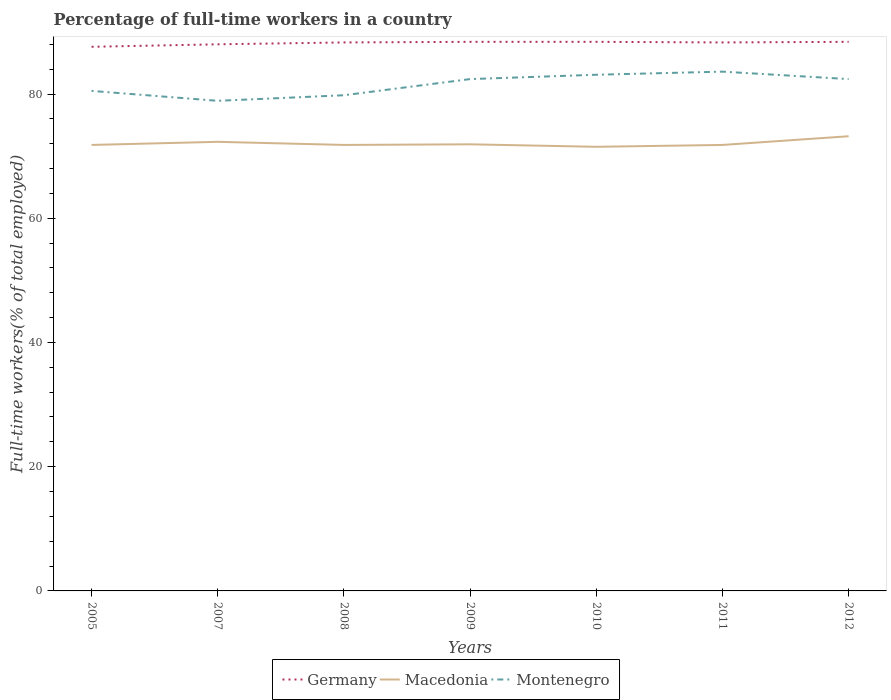Across all years, what is the maximum percentage of full-time workers in Montenegro?
Your answer should be very brief. 78.9. In which year was the percentage of full-time workers in Macedonia maximum?
Ensure brevity in your answer.  2010. What is the total percentage of full-time workers in Montenegro in the graph?
Your answer should be compact. -1.9. What is the difference between the highest and the second highest percentage of full-time workers in Montenegro?
Provide a short and direct response. 4.7. What is the difference between the highest and the lowest percentage of full-time workers in Montenegro?
Your answer should be very brief. 4. Are the values on the major ticks of Y-axis written in scientific E-notation?
Offer a very short reply. No. Does the graph contain grids?
Keep it short and to the point. No. What is the title of the graph?
Give a very brief answer. Percentage of full-time workers in a country. Does "St. Kitts and Nevis" appear as one of the legend labels in the graph?
Provide a short and direct response. No. What is the label or title of the Y-axis?
Keep it short and to the point. Full-time workers(% of total employed). What is the Full-time workers(% of total employed) of Germany in 2005?
Your answer should be very brief. 87.6. What is the Full-time workers(% of total employed) in Macedonia in 2005?
Ensure brevity in your answer.  71.8. What is the Full-time workers(% of total employed) of Montenegro in 2005?
Your answer should be compact. 80.5. What is the Full-time workers(% of total employed) in Germany in 2007?
Your answer should be very brief. 88. What is the Full-time workers(% of total employed) of Macedonia in 2007?
Provide a short and direct response. 72.3. What is the Full-time workers(% of total employed) of Montenegro in 2007?
Ensure brevity in your answer.  78.9. What is the Full-time workers(% of total employed) in Germany in 2008?
Ensure brevity in your answer.  88.3. What is the Full-time workers(% of total employed) of Macedonia in 2008?
Provide a short and direct response. 71.8. What is the Full-time workers(% of total employed) in Montenegro in 2008?
Provide a succinct answer. 79.8. What is the Full-time workers(% of total employed) in Germany in 2009?
Provide a succinct answer. 88.4. What is the Full-time workers(% of total employed) of Macedonia in 2009?
Ensure brevity in your answer.  71.9. What is the Full-time workers(% of total employed) of Montenegro in 2009?
Provide a short and direct response. 82.4. What is the Full-time workers(% of total employed) in Germany in 2010?
Ensure brevity in your answer.  88.4. What is the Full-time workers(% of total employed) in Macedonia in 2010?
Your answer should be compact. 71.5. What is the Full-time workers(% of total employed) of Montenegro in 2010?
Your answer should be very brief. 83.1. What is the Full-time workers(% of total employed) in Germany in 2011?
Your response must be concise. 88.3. What is the Full-time workers(% of total employed) in Macedonia in 2011?
Your response must be concise. 71.8. What is the Full-time workers(% of total employed) of Montenegro in 2011?
Ensure brevity in your answer.  83.6. What is the Full-time workers(% of total employed) in Germany in 2012?
Make the answer very short. 88.4. What is the Full-time workers(% of total employed) of Macedonia in 2012?
Offer a very short reply. 73.2. What is the Full-time workers(% of total employed) of Montenegro in 2012?
Make the answer very short. 82.4. Across all years, what is the maximum Full-time workers(% of total employed) in Germany?
Provide a short and direct response. 88.4. Across all years, what is the maximum Full-time workers(% of total employed) in Macedonia?
Make the answer very short. 73.2. Across all years, what is the maximum Full-time workers(% of total employed) of Montenegro?
Your response must be concise. 83.6. Across all years, what is the minimum Full-time workers(% of total employed) of Germany?
Ensure brevity in your answer.  87.6. Across all years, what is the minimum Full-time workers(% of total employed) in Macedonia?
Your response must be concise. 71.5. Across all years, what is the minimum Full-time workers(% of total employed) of Montenegro?
Your response must be concise. 78.9. What is the total Full-time workers(% of total employed) of Germany in the graph?
Provide a short and direct response. 617.4. What is the total Full-time workers(% of total employed) of Macedonia in the graph?
Your response must be concise. 504.3. What is the total Full-time workers(% of total employed) in Montenegro in the graph?
Ensure brevity in your answer.  570.7. What is the difference between the Full-time workers(% of total employed) in Montenegro in 2005 and that in 2007?
Provide a short and direct response. 1.6. What is the difference between the Full-time workers(% of total employed) of Macedonia in 2005 and that in 2008?
Offer a terse response. 0. What is the difference between the Full-time workers(% of total employed) in Montenegro in 2005 and that in 2008?
Offer a very short reply. 0.7. What is the difference between the Full-time workers(% of total employed) in Germany in 2005 and that in 2009?
Offer a terse response. -0.8. What is the difference between the Full-time workers(% of total employed) in Montenegro in 2005 and that in 2009?
Offer a very short reply. -1.9. What is the difference between the Full-time workers(% of total employed) in Germany in 2005 and that in 2011?
Provide a succinct answer. -0.7. What is the difference between the Full-time workers(% of total employed) of Macedonia in 2005 and that in 2011?
Provide a succinct answer. 0. What is the difference between the Full-time workers(% of total employed) of Macedonia in 2005 and that in 2012?
Offer a very short reply. -1.4. What is the difference between the Full-time workers(% of total employed) in Montenegro in 2005 and that in 2012?
Your response must be concise. -1.9. What is the difference between the Full-time workers(% of total employed) in Germany in 2007 and that in 2008?
Offer a very short reply. -0.3. What is the difference between the Full-time workers(% of total employed) of Germany in 2007 and that in 2009?
Keep it short and to the point. -0.4. What is the difference between the Full-time workers(% of total employed) in Macedonia in 2007 and that in 2009?
Provide a short and direct response. 0.4. What is the difference between the Full-time workers(% of total employed) in Montenegro in 2007 and that in 2009?
Your response must be concise. -3.5. What is the difference between the Full-time workers(% of total employed) of Montenegro in 2007 and that in 2010?
Make the answer very short. -4.2. What is the difference between the Full-time workers(% of total employed) in Germany in 2007 and that in 2011?
Offer a very short reply. -0.3. What is the difference between the Full-time workers(% of total employed) of Germany in 2007 and that in 2012?
Your response must be concise. -0.4. What is the difference between the Full-time workers(% of total employed) of Montenegro in 2007 and that in 2012?
Provide a succinct answer. -3.5. What is the difference between the Full-time workers(% of total employed) of Germany in 2008 and that in 2009?
Ensure brevity in your answer.  -0.1. What is the difference between the Full-time workers(% of total employed) in Montenegro in 2008 and that in 2009?
Your answer should be compact. -2.6. What is the difference between the Full-time workers(% of total employed) of Germany in 2008 and that in 2010?
Ensure brevity in your answer.  -0.1. What is the difference between the Full-time workers(% of total employed) in Macedonia in 2008 and that in 2010?
Offer a very short reply. 0.3. What is the difference between the Full-time workers(% of total employed) in Montenegro in 2008 and that in 2010?
Give a very brief answer. -3.3. What is the difference between the Full-time workers(% of total employed) of Germany in 2008 and that in 2011?
Keep it short and to the point. 0. What is the difference between the Full-time workers(% of total employed) in Montenegro in 2008 and that in 2011?
Keep it short and to the point. -3.8. What is the difference between the Full-time workers(% of total employed) in Macedonia in 2008 and that in 2012?
Ensure brevity in your answer.  -1.4. What is the difference between the Full-time workers(% of total employed) of Montenegro in 2009 and that in 2010?
Provide a succinct answer. -0.7. What is the difference between the Full-time workers(% of total employed) of Germany in 2009 and that in 2011?
Ensure brevity in your answer.  0.1. What is the difference between the Full-time workers(% of total employed) in Macedonia in 2009 and that in 2011?
Provide a succinct answer. 0.1. What is the difference between the Full-time workers(% of total employed) in Montenegro in 2009 and that in 2011?
Make the answer very short. -1.2. What is the difference between the Full-time workers(% of total employed) in Germany in 2009 and that in 2012?
Your response must be concise. 0. What is the difference between the Full-time workers(% of total employed) of Macedonia in 2010 and that in 2011?
Provide a succinct answer. -0.3. What is the difference between the Full-time workers(% of total employed) of Montenegro in 2010 and that in 2011?
Your response must be concise. -0.5. What is the difference between the Full-time workers(% of total employed) of Montenegro in 2010 and that in 2012?
Give a very brief answer. 0.7. What is the difference between the Full-time workers(% of total employed) in Germany in 2011 and that in 2012?
Provide a succinct answer. -0.1. What is the difference between the Full-time workers(% of total employed) of Montenegro in 2011 and that in 2012?
Your answer should be compact. 1.2. What is the difference between the Full-time workers(% of total employed) in Germany in 2005 and the Full-time workers(% of total employed) in Macedonia in 2007?
Ensure brevity in your answer.  15.3. What is the difference between the Full-time workers(% of total employed) in Germany in 2005 and the Full-time workers(% of total employed) in Montenegro in 2007?
Your answer should be compact. 8.7. What is the difference between the Full-time workers(% of total employed) in Macedonia in 2005 and the Full-time workers(% of total employed) in Montenegro in 2007?
Offer a terse response. -7.1. What is the difference between the Full-time workers(% of total employed) of Germany in 2005 and the Full-time workers(% of total employed) of Macedonia in 2009?
Keep it short and to the point. 15.7. What is the difference between the Full-time workers(% of total employed) in Macedonia in 2005 and the Full-time workers(% of total employed) in Montenegro in 2009?
Provide a short and direct response. -10.6. What is the difference between the Full-time workers(% of total employed) in Germany in 2005 and the Full-time workers(% of total employed) in Macedonia in 2010?
Provide a succinct answer. 16.1. What is the difference between the Full-time workers(% of total employed) of Macedonia in 2005 and the Full-time workers(% of total employed) of Montenegro in 2012?
Ensure brevity in your answer.  -10.6. What is the difference between the Full-time workers(% of total employed) of Macedonia in 2007 and the Full-time workers(% of total employed) of Montenegro in 2008?
Your response must be concise. -7.5. What is the difference between the Full-time workers(% of total employed) in Germany in 2007 and the Full-time workers(% of total employed) in Montenegro in 2009?
Your response must be concise. 5.6. What is the difference between the Full-time workers(% of total employed) in Macedonia in 2007 and the Full-time workers(% of total employed) in Montenegro in 2009?
Provide a short and direct response. -10.1. What is the difference between the Full-time workers(% of total employed) in Germany in 2007 and the Full-time workers(% of total employed) in Macedonia in 2010?
Keep it short and to the point. 16.5. What is the difference between the Full-time workers(% of total employed) of Germany in 2007 and the Full-time workers(% of total employed) of Montenegro in 2010?
Keep it short and to the point. 4.9. What is the difference between the Full-time workers(% of total employed) in Germany in 2007 and the Full-time workers(% of total employed) in Macedonia in 2011?
Provide a short and direct response. 16.2. What is the difference between the Full-time workers(% of total employed) in Germany in 2007 and the Full-time workers(% of total employed) in Macedonia in 2012?
Offer a terse response. 14.8. What is the difference between the Full-time workers(% of total employed) in Germany in 2007 and the Full-time workers(% of total employed) in Montenegro in 2012?
Keep it short and to the point. 5.6. What is the difference between the Full-time workers(% of total employed) in Macedonia in 2007 and the Full-time workers(% of total employed) in Montenegro in 2012?
Provide a succinct answer. -10.1. What is the difference between the Full-time workers(% of total employed) in Germany in 2008 and the Full-time workers(% of total employed) in Macedonia in 2009?
Your answer should be compact. 16.4. What is the difference between the Full-time workers(% of total employed) of Germany in 2008 and the Full-time workers(% of total employed) of Macedonia in 2010?
Offer a very short reply. 16.8. What is the difference between the Full-time workers(% of total employed) of Macedonia in 2008 and the Full-time workers(% of total employed) of Montenegro in 2010?
Provide a short and direct response. -11.3. What is the difference between the Full-time workers(% of total employed) of Germany in 2008 and the Full-time workers(% of total employed) of Macedonia in 2011?
Offer a terse response. 16.5. What is the difference between the Full-time workers(% of total employed) of Germany in 2008 and the Full-time workers(% of total employed) of Montenegro in 2011?
Give a very brief answer. 4.7. What is the difference between the Full-time workers(% of total employed) of Macedonia in 2008 and the Full-time workers(% of total employed) of Montenegro in 2011?
Make the answer very short. -11.8. What is the difference between the Full-time workers(% of total employed) of Germany in 2008 and the Full-time workers(% of total employed) of Montenegro in 2012?
Ensure brevity in your answer.  5.9. What is the difference between the Full-time workers(% of total employed) in Germany in 2009 and the Full-time workers(% of total employed) in Macedonia in 2010?
Offer a terse response. 16.9. What is the difference between the Full-time workers(% of total employed) of Germany in 2009 and the Full-time workers(% of total employed) of Montenegro in 2010?
Make the answer very short. 5.3. What is the difference between the Full-time workers(% of total employed) of Macedonia in 2009 and the Full-time workers(% of total employed) of Montenegro in 2010?
Provide a short and direct response. -11.2. What is the difference between the Full-time workers(% of total employed) of Germany in 2009 and the Full-time workers(% of total employed) of Macedonia in 2012?
Offer a very short reply. 15.2. What is the difference between the Full-time workers(% of total employed) in Germany in 2009 and the Full-time workers(% of total employed) in Montenegro in 2012?
Your response must be concise. 6. What is the difference between the Full-time workers(% of total employed) of Macedonia in 2009 and the Full-time workers(% of total employed) of Montenegro in 2012?
Your response must be concise. -10.5. What is the difference between the Full-time workers(% of total employed) of Macedonia in 2010 and the Full-time workers(% of total employed) of Montenegro in 2011?
Provide a short and direct response. -12.1. What is the difference between the Full-time workers(% of total employed) in Germany in 2010 and the Full-time workers(% of total employed) in Macedonia in 2012?
Make the answer very short. 15.2. What is the difference between the Full-time workers(% of total employed) of Germany in 2010 and the Full-time workers(% of total employed) of Montenegro in 2012?
Keep it short and to the point. 6. What is the difference between the Full-time workers(% of total employed) in Macedonia in 2010 and the Full-time workers(% of total employed) in Montenegro in 2012?
Provide a short and direct response. -10.9. What is the difference between the Full-time workers(% of total employed) in Germany in 2011 and the Full-time workers(% of total employed) in Macedonia in 2012?
Make the answer very short. 15.1. What is the difference between the Full-time workers(% of total employed) in Macedonia in 2011 and the Full-time workers(% of total employed) in Montenegro in 2012?
Your answer should be compact. -10.6. What is the average Full-time workers(% of total employed) in Germany per year?
Provide a succinct answer. 88.2. What is the average Full-time workers(% of total employed) of Macedonia per year?
Ensure brevity in your answer.  72.04. What is the average Full-time workers(% of total employed) in Montenegro per year?
Your answer should be compact. 81.53. In the year 2005, what is the difference between the Full-time workers(% of total employed) in Macedonia and Full-time workers(% of total employed) in Montenegro?
Give a very brief answer. -8.7. In the year 2007, what is the difference between the Full-time workers(% of total employed) of Germany and Full-time workers(% of total employed) of Macedonia?
Offer a terse response. 15.7. In the year 2007, what is the difference between the Full-time workers(% of total employed) in Macedonia and Full-time workers(% of total employed) in Montenegro?
Your answer should be compact. -6.6. In the year 2008, what is the difference between the Full-time workers(% of total employed) in Macedonia and Full-time workers(% of total employed) in Montenegro?
Your answer should be very brief. -8. In the year 2010, what is the difference between the Full-time workers(% of total employed) of Germany and Full-time workers(% of total employed) of Macedonia?
Provide a succinct answer. 16.9. In the year 2010, what is the difference between the Full-time workers(% of total employed) in Germany and Full-time workers(% of total employed) in Montenegro?
Offer a terse response. 5.3. In the year 2010, what is the difference between the Full-time workers(% of total employed) in Macedonia and Full-time workers(% of total employed) in Montenegro?
Make the answer very short. -11.6. In the year 2011, what is the difference between the Full-time workers(% of total employed) of Germany and Full-time workers(% of total employed) of Macedonia?
Provide a succinct answer. 16.5. What is the ratio of the Full-time workers(% of total employed) of Montenegro in 2005 to that in 2007?
Provide a succinct answer. 1.02. What is the ratio of the Full-time workers(% of total employed) of Montenegro in 2005 to that in 2008?
Your answer should be very brief. 1.01. What is the ratio of the Full-time workers(% of total employed) of Montenegro in 2005 to that in 2009?
Provide a short and direct response. 0.98. What is the ratio of the Full-time workers(% of total employed) in Germany in 2005 to that in 2010?
Ensure brevity in your answer.  0.99. What is the ratio of the Full-time workers(% of total employed) of Macedonia in 2005 to that in 2010?
Ensure brevity in your answer.  1. What is the ratio of the Full-time workers(% of total employed) in Montenegro in 2005 to that in 2010?
Provide a succinct answer. 0.97. What is the ratio of the Full-time workers(% of total employed) of Macedonia in 2005 to that in 2011?
Keep it short and to the point. 1. What is the ratio of the Full-time workers(% of total employed) in Montenegro in 2005 to that in 2011?
Make the answer very short. 0.96. What is the ratio of the Full-time workers(% of total employed) of Macedonia in 2005 to that in 2012?
Your answer should be very brief. 0.98. What is the ratio of the Full-time workers(% of total employed) in Montenegro in 2005 to that in 2012?
Give a very brief answer. 0.98. What is the ratio of the Full-time workers(% of total employed) in Montenegro in 2007 to that in 2008?
Your answer should be very brief. 0.99. What is the ratio of the Full-time workers(% of total employed) in Macedonia in 2007 to that in 2009?
Offer a terse response. 1.01. What is the ratio of the Full-time workers(% of total employed) in Montenegro in 2007 to that in 2009?
Your answer should be compact. 0.96. What is the ratio of the Full-time workers(% of total employed) of Germany in 2007 to that in 2010?
Keep it short and to the point. 1. What is the ratio of the Full-time workers(% of total employed) in Macedonia in 2007 to that in 2010?
Give a very brief answer. 1.01. What is the ratio of the Full-time workers(% of total employed) in Montenegro in 2007 to that in 2010?
Offer a terse response. 0.95. What is the ratio of the Full-time workers(% of total employed) of Germany in 2007 to that in 2011?
Offer a terse response. 1. What is the ratio of the Full-time workers(% of total employed) in Montenegro in 2007 to that in 2011?
Ensure brevity in your answer.  0.94. What is the ratio of the Full-time workers(% of total employed) of Germany in 2007 to that in 2012?
Offer a very short reply. 1. What is the ratio of the Full-time workers(% of total employed) of Macedonia in 2007 to that in 2012?
Give a very brief answer. 0.99. What is the ratio of the Full-time workers(% of total employed) in Montenegro in 2007 to that in 2012?
Offer a very short reply. 0.96. What is the ratio of the Full-time workers(% of total employed) in Montenegro in 2008 to that in 2009?
Offer a terse response. 0.97. What is the ratio of the Full-time workers(% of total employed) of Montenegro in 2008 to that in 2010?
Ensure brevity in your answer.  0.96. What is the ratio of the Full-time workers(% of total employed) in Macedonia in 2008 to that in 2011?
Offer a terse response. 1. What is the ratio of the Full-time workers(% of total employed) in Montenegro in 2008 to that in 2011?
Ensure brevity in your answer.  0.95. What is the ratio of the Full-time workers(% of total employed) in Macedonia in 2008 to that in 2012?
Ensure brevity in your answer.  0.98. What is the ratio of the Full-time workers(% of total employed) in Montenegro in 2008 to that in 2012?
Make the answer very short. 0.97. What is the ratio of the Full-time workers(% of total employed) of Macedonia in 2009 to that in 2010?
Your answer should be very brief. 1.01. What is the ratio of the Full-time workers(% of total employed) in Montenegro in 2009 to that in 2010?
Your answer should be very brief. 0.99. What is the ratio of the Full-time workers(% of total employed) of Montenegro in 2009 to that in 2011?
Ensure brevity in your answer.  0.99. What is the ratio of the Full-time workers(% of total employed) in Macedonia in 2009 to that in 2012?
Make the answer very short. 0.98. What is the ratio of the Full-time workers(% of total employed) in Montenegro in 2009 to that in 2012?
Give a very brief answer. 1. What is the ratio of the Full-time workers(% of total employed) of Germany in 2010 to that in 2012?
Your answer should be very brief. 1. What is the ratio of the Full-time workers(% of total employed) in Macedonia in 2010 to that in 2012?
Provide a succinct answer. 0.98. What is the ratio of the Full-time workers(% of total employed) of Montenegro in 2010 to that in 2012?
Keep it short and to the point. 1.01. What is the ratio of the Full-time workers(% of total employed) in Germany in 2011 to that in 2012?
Ensure brevity in your answer.  1. What is the ratio of the Full-time workers(% of total employed) of Macedonia in 2011 to that in 2012?
Offer a terse response. 0.98. What is the ratio of the Full-time workers(% of total employed) of Montenegro in 2011 to that in 2012?
Give a very brief answer. 1.01. What is the difference between the highest and the second highest Full-time workers(% of total employed) in Macedonia?
Make the answer very short. 0.9. 